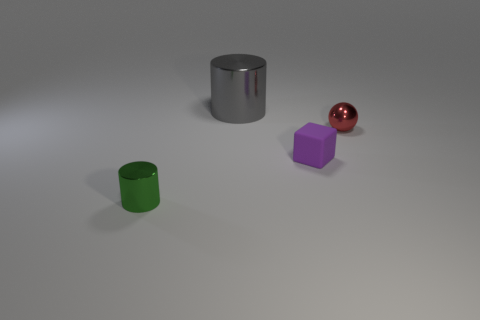Add 3 large brown metallic blocks. How many objects exist? 7 Subtract all balls. How many objects are left? 3 Add 2 red metallic spheres. How many red metallic spheres are left? 3 Add 2 red rubber cylinders. How many red rubber cylinders exist? 2 Subtract 0 blue spheres. How many objects are left? 4 Subtract all red things. Subtract all big gray matte things. How many objects are left? 3 